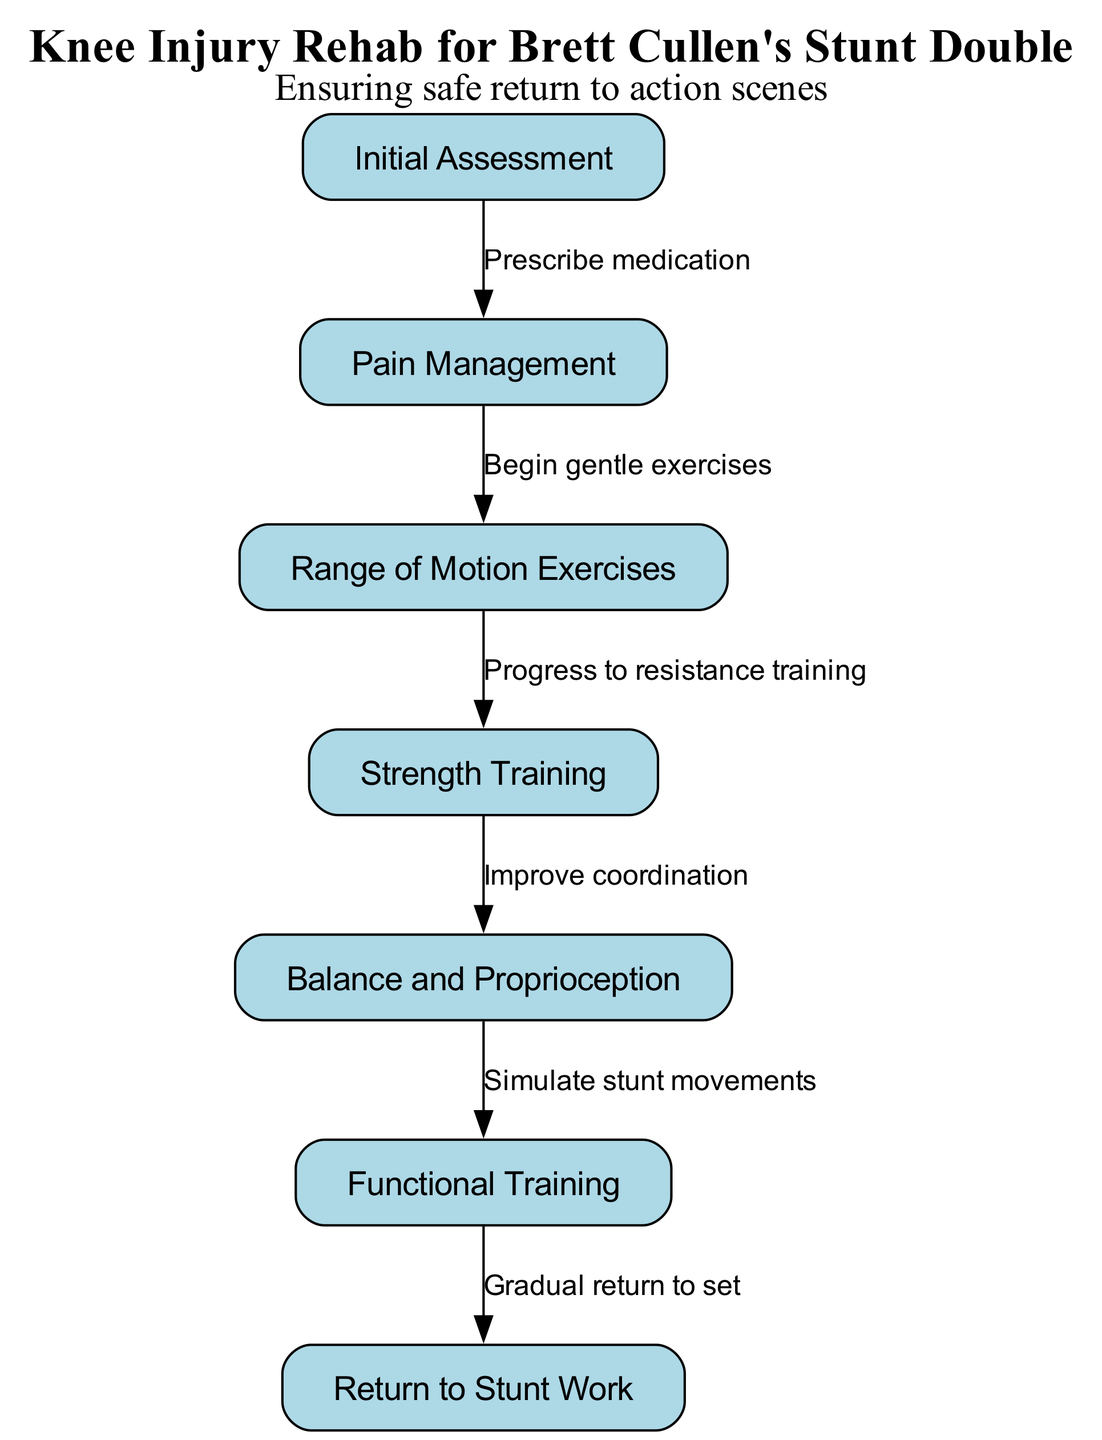What is the first step in the rehabilitation pathway? The first node in the diagram indicates "Initial Assessment," which is the starting point of the pathway.
Answer: Initial Assessment How many nodes are present in the diagram? By counting the individual nodes listed in the data under "nodes," there are a total of 7 nodes.
Answer: 7 What is the last step before returning to stunt work? According to the edges, the last node prior to "Return to Stunt Work" is "Functional Training", which indicates the final step before resuming stunt activities.
Answer: Functional Training What type of exercises begin after pain management? The edge connecting "Pain Management" to "Range of Motion Exercises" suggests that after pain management, the pathway advances to the initiation of gentle exercises, specifically "Range of Motion Exercises."
Answer: Range of Motion Exercises Which node focuses on improving coordination? The diagram shows that the node labeled "Balance and Proprioception" is directly linked to the "Strength Training" node, as its purpose is to enhance coordination.
Answer: Balance and Proprioception What is the relationship between "Initial Assessment" and "Pain Management"? The edge labeled "Prescribe medication" connects "Initial Assessment" to "Pain Management," indicating that pain management is prescribed following the initial assessment.
Answer: Prescribe medication What step follows "Strength Training"? From the diagram, "Balance and Proprioception" is the immediate next step that follows "Strength Training," emphasizing the improvement of coordination afterward.
Answer: Balance and Proprioception How do performers progress from functional training to returning to stunt work? The edge labeled "Gradual return to set" shows that performers move from "Functional Training" directly to the final stage of "Return to Stunt Work."
Answer: Gradual return to set 